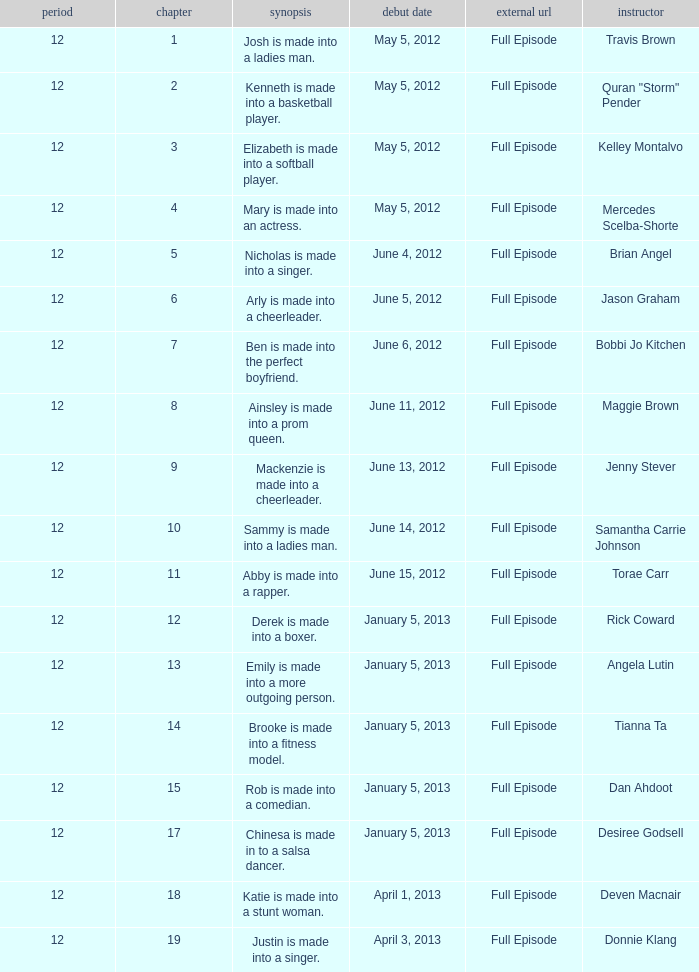Name the coach for  emily is made into a more outgoing person. Angela Lutin. 